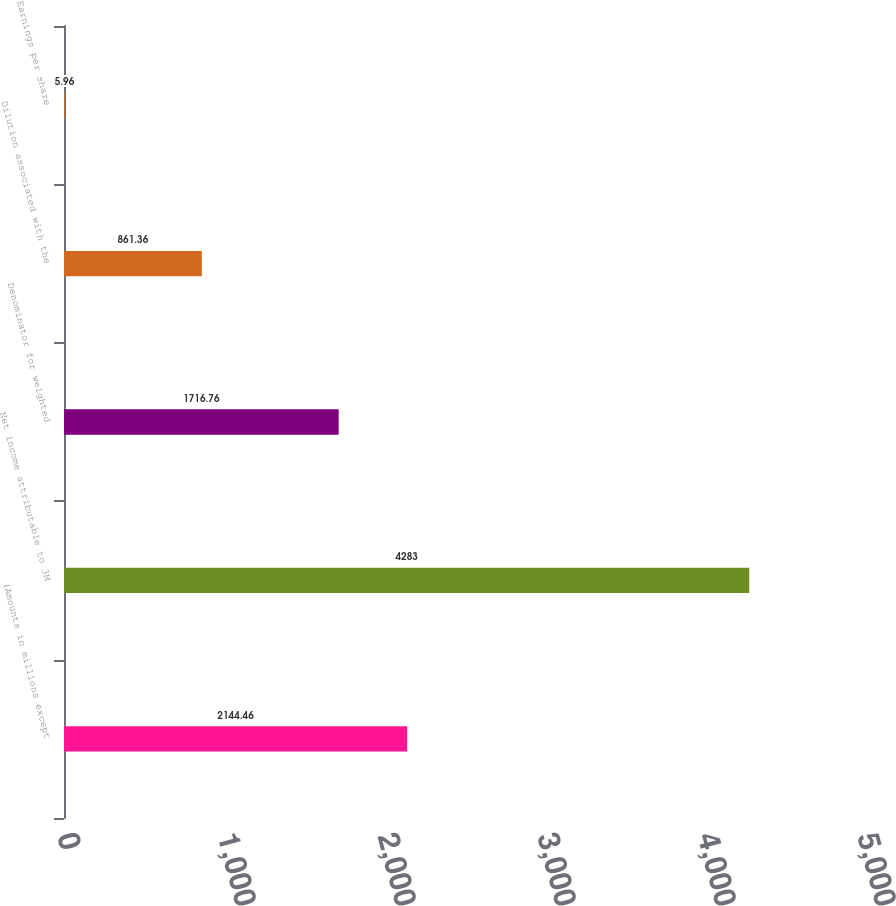<chart> <loc_0><loc_0><loc_500><loc_500><bar_chart><fcel>(Amounts in millions except<fcel>Net income attributable to 3M<fcel>Denominator for weighted<fcel>Dilution associated with the<fcel>Earnings per share<nl><fcel>2144.46<fcel>4283<fcel>1716.76<fcel>861.36<fcel>5.96<nl></chart> 